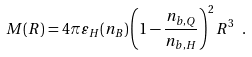Convert formula to latex. <formula><loc_0><loc_0><loc_500><loc_500>M ( R ) = 4 \pi \varepsilon _ { H } ( n _ { B } ) \left ( 1 - \frac { n _ { b , Q } } { n _ { b , H } } \right ) ^ { 2 } R ^ { 3 } \ .</formula> 